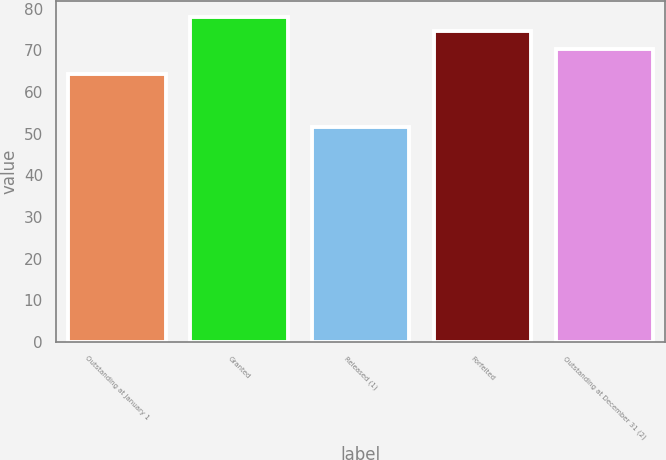Convert chart. <chart><loc_0><loc_0><loc_500><loc_500><bar_chart><fcel>Outstanding at January 1<fcel>Granted<fcel>Released (1)<fcel>Forfeited<fcel>Outstanding at December 31 (2)<nl><fcel>64.39<fcel>77.94<fcel>51.52<fcel>74.56<fcel>70.35<nl></chart> 